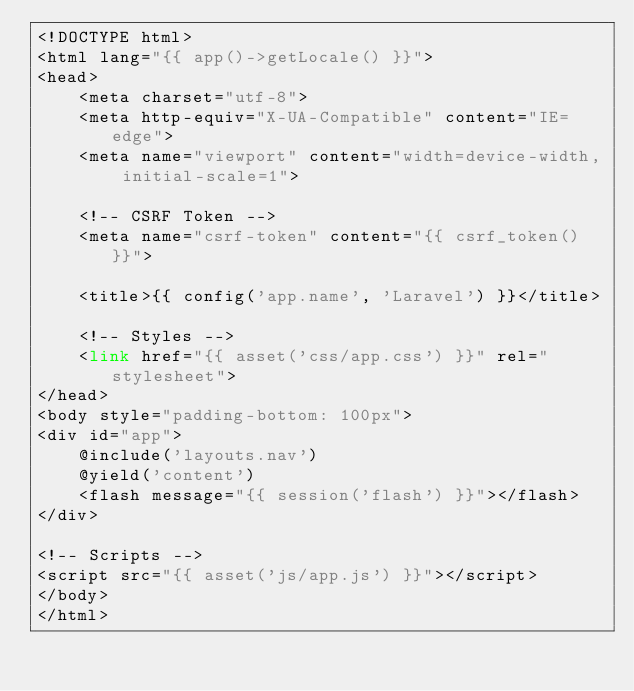Convert code to text. <code><loc_0><loc_0><loc_500><loc_500><_PHP_><!DOCTYPE html>
<html lang="{{ app()->getLocale() }}">
<head>
    <meta charset="utf-8">
    <meta http-equiv="X-UA-Compatible" content="IE=edge">
    <meta name="viewport" content="width=device-width, initial-scale=1">

    <!-- CSRF Token -->
    <meta name="csrf-token" content="{{ csrf_token() }}">

    <title>{{ config('app.name', 'Laravel') }}</title>

    <!-- Styles -->
    <link href="{{ asset('css/app.css') }}" rel="stylesheet">
</head>
<body style="padding-bottom: 100px">
<div id="app">
    @include('layouts.nav')
    @yield('content')
    <flash message="{{ session('flash') }}"></flash>
</div>

<!-- Scripts -->
<script src="{{ asset('js/app.js') }}"></script>
</body>
</html>
</code> 